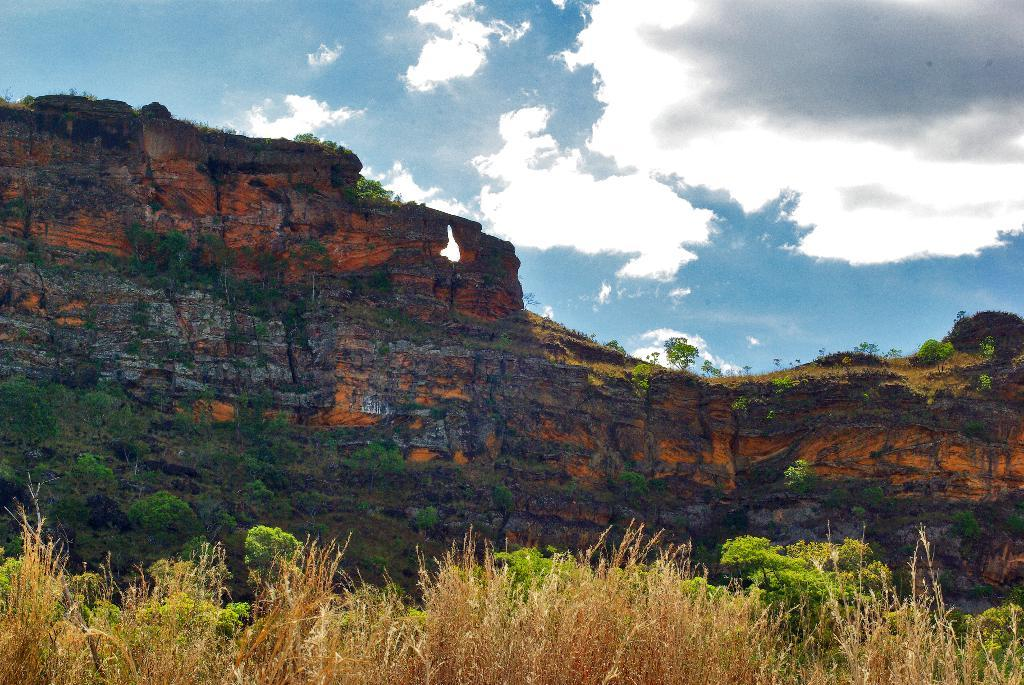What type of vegetation is visible in the front of the image? There is dry grass in the front of the image. What else can be seen in the image besides the dry grass? There are plants in the image. What is located in the background of the image? There is a wall in the background of the image. How would you describe the sky in the image? The sky is cloudy in the image. Where is the pail located in the image? There is no pail present in the image. What type of finger can be seen interacting with the plants in the image? There are no fingers visible in the image; it only shows plants and dry grass. 